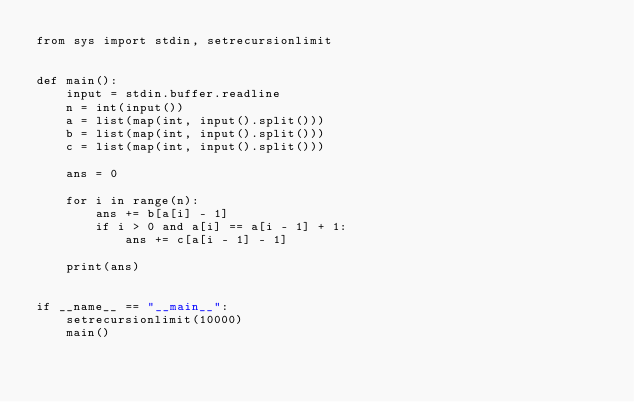<code> <loc_0><loc_0><loc_500><loc_500><_Python_>from sys import stdin, setrecursionlimit


def main():
    input = stdin.buffer.readline
    n = int(input())
    a = list(map(int, input().split()))
    b = list(map(int, input().split()))
    c = list(map(int, input().split()))

    ans = 0

    for i in range(n):
        ans += b[a[i] - 1]
        if i > 0 and a[i] == a[i - 1] + 1:
            ans += c[a[i - 1] - 1]

    print(ans)


if __name__ == "__main__":
    setrecursionlimit(10000)
    main()
</code> 